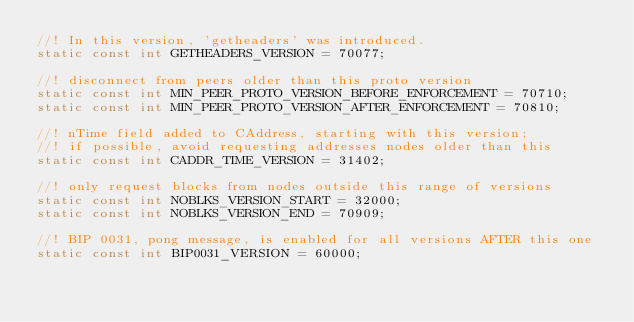<code> <loc_0><loc_0><loc_500><loc_500><_C_>//! In this version, 'getheaders' was introduced.
static const int GETHEADERS_VERSION = 70077;

//! disconnect from peers older than this proto version
static const int MIN_PEER_PROTO_VERSION_BEFORE_ENFORCEMENT = 70710;
static const int MIN_PEER_PROTO_VERSION_AFTER_ENFORCEMENT = 70810;

//! nTime field added to CAddress, starting with this version;
//! if possible, avoid requesting addresses nodes older than this
static const int CADDR_TIME_VERSION = 31402;

//! only request blocks from nodes outside this range of versions
static const int NOBLKS_VERSION_START = 32000;
static const int NOBLKS_VERSION_END = 70909;

//! BIP 0031, pong message, is enabled for all versions AFTER this one
static const int BIP0031_VERSION = 60000;
</code> 